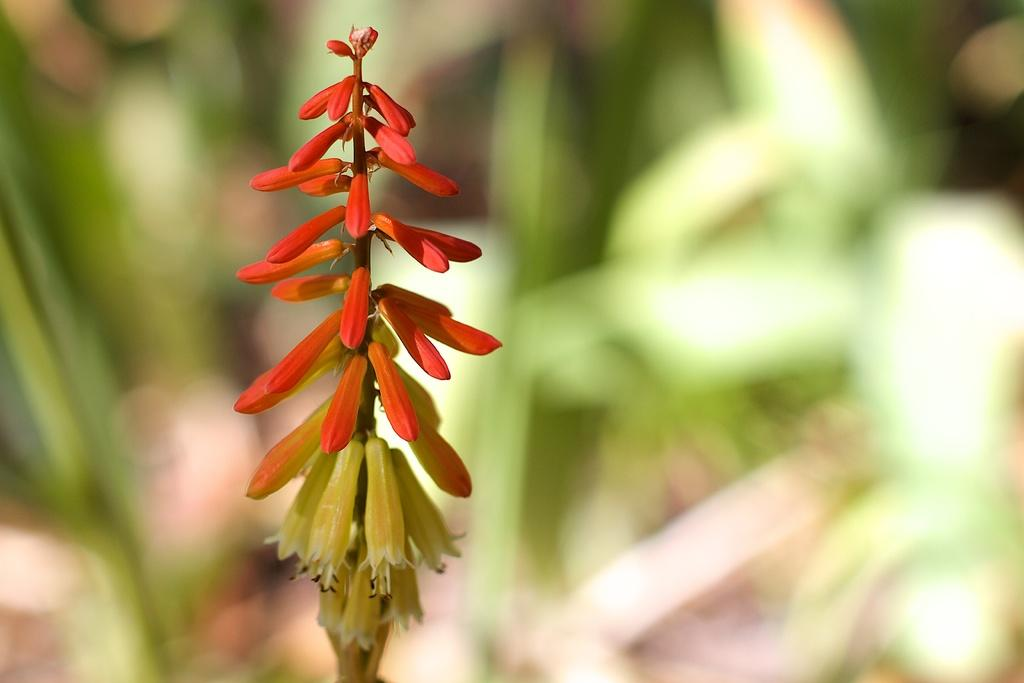What type of plant is visible in the image? There are flowers with stems in the image. How is the background of the image depicted? The background has a blurred view. What color can be seen in the image? The color green is present in the image. What type of hat is visible in the image? There is no hat present in the image. What is the belief of the flowers in the image? The flowers in the image do not have beliefs, as they are inanimate objects. 